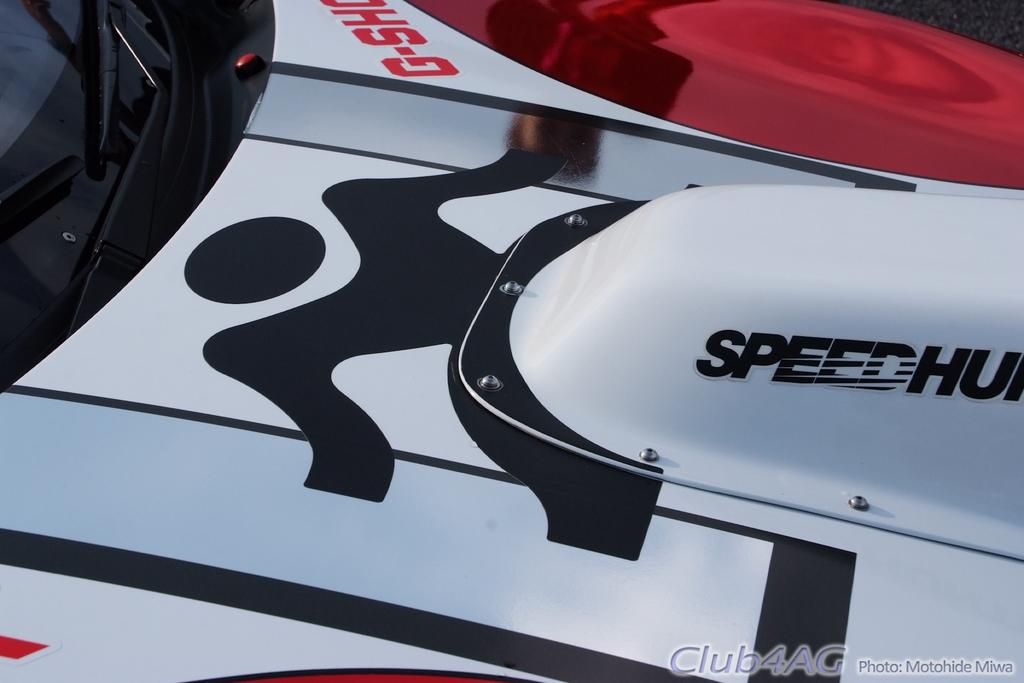What is the main subject of the image? There is a vehicle in the image. What colors can be seen on the vehicle? The vehicle has white, black, and red colors. What is in front of the vehicle? There is a glass in front of the vehicle. What is written on the glass? Something is written on the glass. Can you tell me how many hands are visible in the image? There are no hands visible in the image. What type of fight is taking place in the image? There is no fight present in the image. 